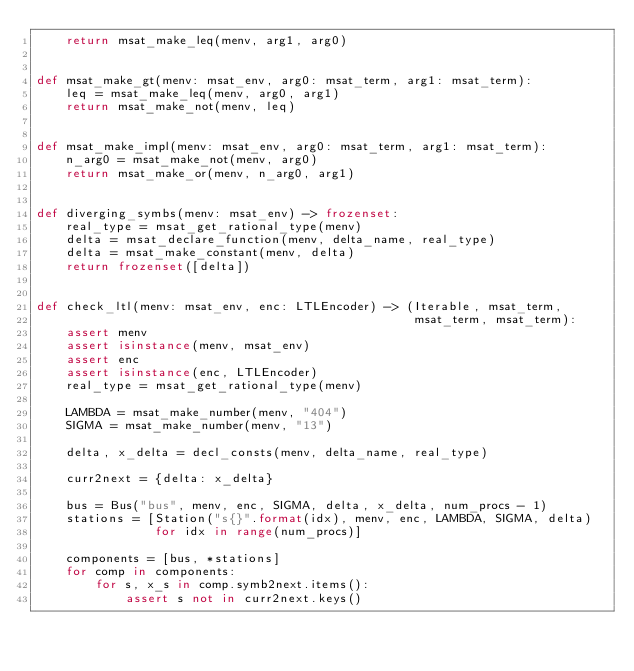<code> <loc_0><loc_0><loc_500><loc_500><_Python_>    return msat_make_leq(menv, arg1, arg0)


def msat_make_gt(menv: msat_env, arg0: msat_term, arg1: msat_term):
    leq = msat_make_leq(menv, arg0, arg1)
    return msat_make_not(menv, leq)


def msat_make_impl(menv: msat_env, arg0: msat_term, arg1: msat_term):
    n_arg0 = msat_make_not(menv, arg0)
    return msat_make_or(menv, n_arg0, arg1)


def diverging_symbs(menv: msat_env) -> frozenset:
    real_type = msat_get_rational_type(menv)
    delta = msat_declare_function(menv, delta_name, real_type)
    delta = msat_make_constant(menv, delta)
    return frozenset([delta])


def check_ltl(menv: msat_env, enc: LTLEncoder) -> (Iterable, msat_term,
                                                   msat_term, msat_term):
    assert menv
    assert isinstance(menv, msat_env)
    assert enc
    assert isinstance(enc, LTLEncoder)
    real_type = msat_get_rational_type(menv)

    LAMBDA = msat_make_number(menv, "404")
    SIGMA = msat_make_number(menv, "13")

    delta, x_delta = decl_consts(menv, delta_name, real_type)

    curr2next = {delta: x_delta}

    bus = Bus("bus", menv, enc, SIGMA, delta, x_delta, num_procs - 1)
    stations = [Station("s{}".format(idx), menv, enc, LAMBDA, SIGMA, delta)
                for idx in range(num_procs)]

    components = [bus, *stations]
    for comp in components:
        for s, x_s in comp.symb2next.items():
            assert s not in curr2next.keys()</code> 